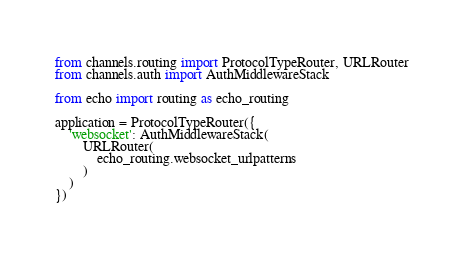<code> <loc_0><loc_0><loc_500><loc_500><_Python_>from channels.routing import ProtocolTypeRouter, URLRouter
from channels.auth import AuthMiddlewareStack

from echo import routing as echo_routing

application = ProtocolTypeRouter({
    'websocket': AuthMiddlewareStack(
        URLRouter(
            echo_routing.websocket_urlpatterns
        )
    )
})</code> 